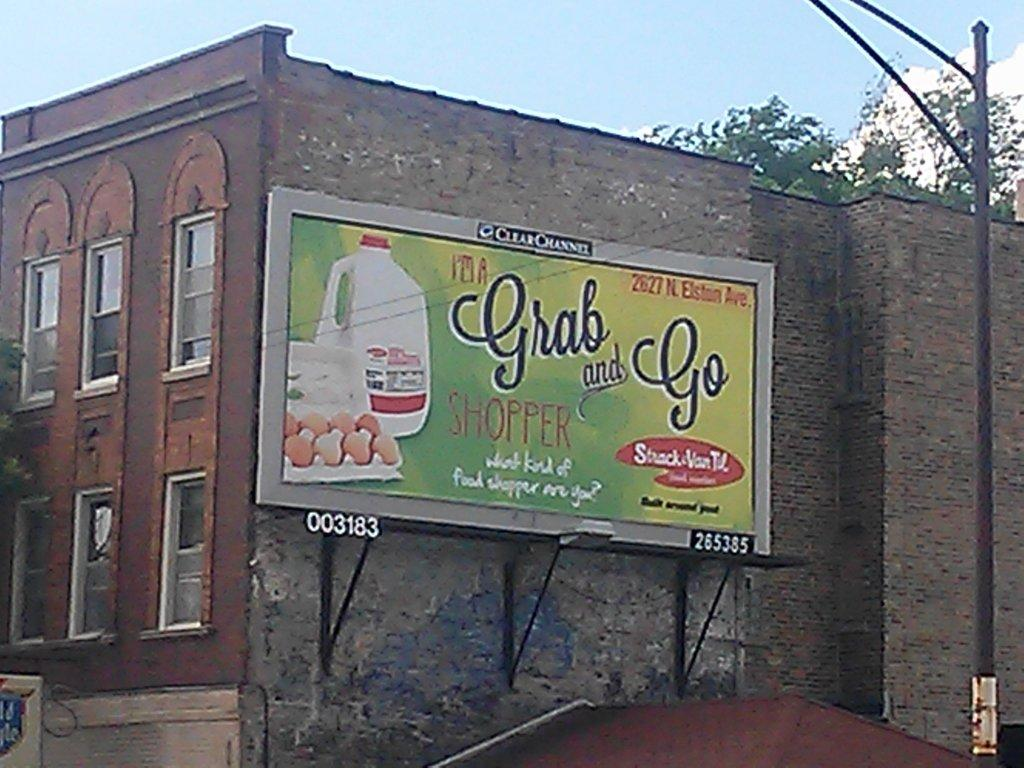Provide a one-sentence caption for the provided image. A billboard saying I'm a grab and go shopper. 